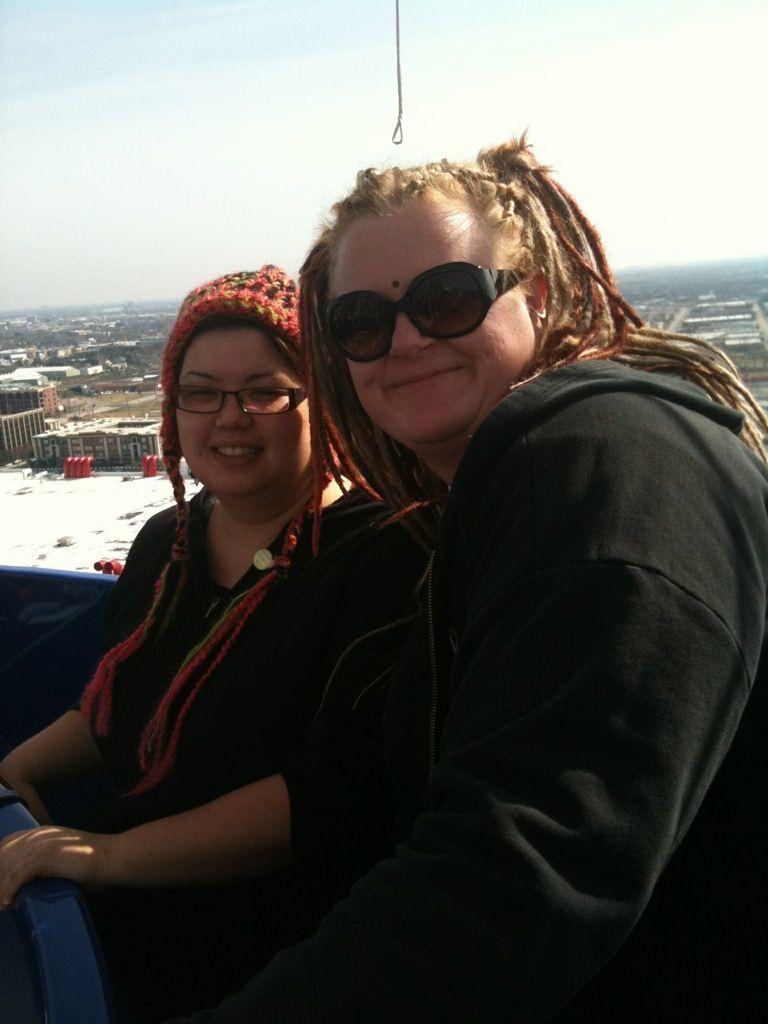How many people are in the image? There are two people in the image. What are the people wearing? Both people are wearing black dresses. What can be seen in the background of the image? There are buildings and sheds in the background of the image. What is visible in the sky in the image? Clouds are visible in the sky. What part of the natural environment is visible in the image? The sky is visible in the image. What type of hand can be seen holding a copy of the coast in the image? There is no hand or coast present in the image. 